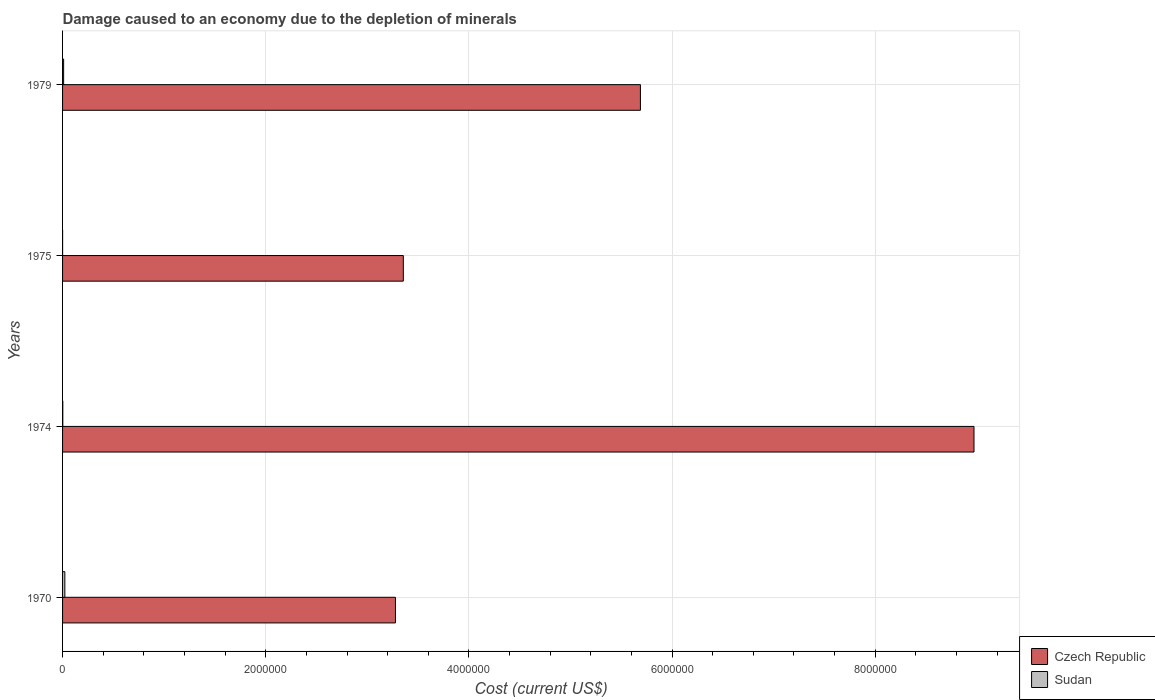How many groups of bars are there?
Provide a short and direct response. 4. Are the number of bars per tick equal to the number of legend labels?
Provide a short and direct response. Yes. How many bars are there on the 1st tick from the bottom?
Ensure brevity in your answer.  2. What is the label of the 2nd group of bars from the top?
Ensure brevity in your answer.  1975. What is the cost of damage caused due to the depletion of minerals in Czech Republic in 1974?
Keep it short and to the point. 8.97e+06. Across all years, what is the maximum cost of damage caused due to the depletion of minerals in Czech Republic?
Ensure brevity in your answer.  8.97e+06. Across all years, what is the minimum cost of damage caused due to the depletion of minerals in Czech Republic?
Your answer should be very brief. 3.28e+06. In which year was the cost of damage caused due to the depletion of minerals in Czech Republic maximum?
Your response must be concise. 1974. In which year was the cost of damage caused due to the depletion of minerals in Sudan minimum?
Offer a very short reply. 1975. What is the total cost of damage caused due to the depletion of minerals in Sudan in the graph?
Make the answer very short. 3.54e+04. What is the difference between the cost of damage caused due to the depletion of minerals in Czech Republic in 1970 and that in 1979?
Give a very brief answer. -2.41e+06. What is the difference between the cost of damage caused due to the depletion of minerals in Czech Republic in 1975 and the cost of damage caused due to the depletion of minerals in Sudan in 1974?
Your answer should be compact. 3.35e+06. What is the average cost of damage caused due to the depletion of minerals in Czech Republic per year?
Provide a succinct answer. 5.32e+06. In the year 1979, what is the difference between the cost of damage caused due to the depletion of minerals in Czech Republic and cost of damage caused due to the depletion of minerals in Sudan?
Ensure brevity in your answer.  5.68e+06. What is the ratio of the cost of damage caused due to the depletion of minerals in Sudan in 1975 to that in 1979?
Offer a terse response. 0.02. Is the cost of damage caused due to the depletion of minerals in Sudan in 1975 less than that in 1979?
Ensure brevity in your answer.  Yes. What is the difference between the highest and the second highest cost of damage caused due to the depletion of minerals in Sudan?
Provide a short and direct response. 1.20e+04. What is the difference between the highest and the lowest cost of damage caused due to the depletion of minerals in Czech Republic?
Your response must be concise. 5.69e+06. In how many years, is the cost of damage caused due to the depletion of minerals in Czech Republic greater than the average cost of damage caused due to the depletion of minerals in Czech Republic taken over all years?
Make the answer very short. 2. What does the 2nd bar from the top in 1975 represents?
Provide a short and direct response. Czech Republic. What does the 1st bar from the bottom in 1975 represents?
Your answer should be compact. Czech Republic. How many bars are there?
Offer a terse response. 8. Are all the bars in the graph horizontal?
Make the answer very short. Yes. How many years are there in the graph?
Your answer should be compact. 4. Are the values on the major ticks of X-axis written in scientific E-notation?
Provide a short and direct response. No. Does the graph contain any zero values?
Keep it short and to the point. No. Where does the legend appear in the graph?
Keep it short and to the point. Bottom right. What is the title of the graph?
Offer a very short reply. Damage caused to an economy due to the depletion of minerals. What is the label or title of the X-axis?
Provide a succinct answer. Cost (current US$). What is the Cost (current US$) in Czech Republic in 1970?
Ensure brevity in your answer.  3.28e+06. What is the Cost (current US$) of Sudan in 1970?
Ensure brevity in your answer.  2.24e+04. What is the Cost (current US$) of Czech Republic in 1974?
Your response must be concise. 8.97e+06. What is the Cost (current US$) in Sudan in 1974?
Your response must be concise. 2277.86. What is the Cost (current US$) of Czech Republic in 1975?
Provide a succinct answer. 3.35e+06. What is the Cost (current US$) of Sudan in 1975?
Ensure brevity in your answer.  230.36. What is the Cost (current US$) of Czech Republic in 1979?
Keep it short and to the point. 5.69e+06. What is the Cost (current US$) in Sudan in 1979?
Your answer should be very brief. 1.04e+04. Across all years, what is the maximum Cost (current US$) in Czech Republic?
Your response must be concise. 8.97e+06. Across all years, what is the maximum Cost (current US$) of Sudan?
Your response must be concise. 2.24e+04. Across all years, what is the minimum Cost (current US$) in Czech Republic?
Make the answer very short. 3.28e+06. Across all years, what is the minimum Cost (current US$) in Sudan?
Ensure brevity in your answer.  230.36. What is the total Cost (current US$) of Czech Republic in the graph?
Ensure brevity in your answer.  2.13e+07. What is the total Cost (current US$) in Sudan in the graph?
Ensure brevity in your answer.  3.54e+04. What is the difference between the Cost (current US$) of Czech Republic in 1970 and that in 1974?
Offer a very short reply. -5.69e+06. What is the difference between the Cost (current US$) in Sudan in 1970 and that in 1974?
Make the answer very short. 2.02e+04. What is the difference between the Cost (current US$) in Czech Republic in 1970 and that in 1975?
Provide a succinct answer. -7.71e+04. What is the difference between the Cost (current US$) of Sudan in 1970 and that in 1975?
Offer a terse response. 2.22e+04. What is the difference between the Cost (current US$) in Czech Republic in 1970 and that in 1979?
Your response must be concise. -2.41e+06. What is the difference between the Cost (current US$) of Sudan in 1970 and that in 1979?
Offer a very short reply. 1.20e+04. What is the difference between the Cost (current US$) in Czech Republic in 1974 and that in 1975?
Make the answer very short. 5.62e+06. What is the difference between the Cost (current US$) of Sudan in 1974 and that in 1975?
Your answer should be very brief. 2047.51. What is the difference between the Cost (current US$) in Czech Republic in 1974 and that in 1979?
Your response must be concise. 3.28e+06. What is the difference between the Cost (current US$) of Sudan in 1974 and that in 1979?
Offer a terse response. -8165.14. What is the difference between the Cost (current US$) of Czech Republic in 1975 and that in 1979?
Your answer should be very brief. -2.33e+06. What is the difference between the Cost (current US$) in Sudan in 1975 and that in 1979?
Give a very brief answer. -1.02e+04. What is the difference between the Cost (current US$) of Czech Republic in 1970 and the Cost (current US$) of Sudan in 1974?
Provide a short and direct response. 3.27e+06. What is the difference between the Cost (current US$) in Czech Republic in 1970 and the Cost (current US$) in Sudan in 1975?
Offer a very short reply. 3.28e+06. What is the difference between the Cost (current US$) in Czech Republic in 1970 and the Cost (current US$) in Sudan in 1979?
Keep it short and to the point. 3.27e+06. What is the difference between the Cost (current US$) of Czech Republic in 1974 and the Cost (current US$) of Sudan in 1975?
Make the answer very short. 8.97e+06. What is the difference between the Cost (current US$) in Czech Republic in 1974 and the Cost (current US$) in Sudan in 1979?
Keep it short and to the point. 8.96e+06. What is the difference between the Cost (current US$) in Czech Republic in 1975 and the Cost (current US$) in Sudan in 1979?
Your response must be concise. 3.34e+06. What is the average Cost (current US$) of Czech Republic per year?
Offer a terse response. 5.32e+06. What is the average Cost (current US$) in Sudan per year?
Your answer should be very brief. 8849.35. In the year 1970, what is the difference between the Cost (current US$) in Czech Republic and Cost (current US$) in Sudan?
Provide a succinct answer. 3.25e+06. In the year 1974, what is the difference between the Cost (current US$) in Czech Republic and Cost (current US$) in Sudan?
Give a very brief answer. 8.97e+06. In the year 1975, what is the difference between the Cost (current US$) in Czech Republic and Cost (current US$) in Sudan?
Your answer should be compact. 3.35e+06. In the year 1979, what is the difference between the Cost (current US$) in Czech Republic and Cost (current US$) in Sudan?
Provide a short and direct response. 5.68e+06. What is the ratio of the Cost (current US$) of Czech Republic in 1970 to that in 1974?
Your answer should be compact. 0.37. What is the ratio of the Cost (current US$) of Sudan in 1970 to that in 1974?
Give a very brief answer. 9.85. What is the ratio of the Cost (current US$) of Sudan in 1970 to that in 1975?
Your response must be concise. 97.44. What is the ratio of the Cost (current US$) in Czech Republic in 1970 to that in 1979?
Keep it short and to the point. 0.58. What is the ratio of the Cost (current US$) of Sudan in 1970 to that in 1979?
Provide a succinct answer. 2.15. What is the ratio of the Cost (current US$) in Czech Republic in 1974 to that in 1975?
Offer a very short reply. 2.67. What is the ratio of the Cost (current US$) in Sudan in 1974 to that in 1975?
Provide a succinct answer. 9.89. What is the ratio of the Cost (current US$) in Czech Republic in 1974 to that in 1979?
Your response must be concise. 1.58. What is the ratio of the Cost (current US$) of Sudan in 1974 to that in 1979?
Make the answer very short. 0.22. What is the ratio of the Cost (current US$) in Czech Republic in 1975 to that in 1979?
Your response must be concise. 0.59. What is the ratio of the Cost (current US$) in Sudan in 1975 to that in 1979?
Ensure brevity in your answer.  0.02. What is the difference between the highest and the second highest Cost (current US$) in Czech Republic?
Offer a terse response. 3.28e+06. What is the difference between the highest and the second highest Cost (current US$) in Sudan?
Your answer should be compact. 1.20e+04. What is the difference between the highest and the lowest Cost (current US$) in Czech Republic?
Provide a short and direct response. 5.69e+06. What is the difference between the highest and the lowest Cost (current US$) of Sudan?
Provide a succinct answer. 2.22e+04. 